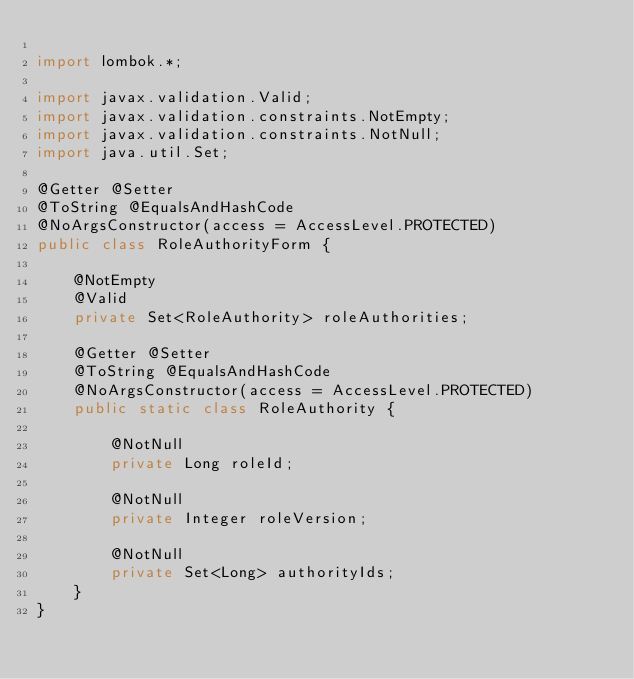<code> <loc_0><loc_0><loc_500><loc_500><_Java_>
import lombok.*;

import javax.validation.Valid;
import javax.validation.constraints.NotEmpty;
import javax.validation.constraints.NotNull;
import java.util.Set;

@Getter @Setter
@ToString @EqualsAndHashCode
@NoArgsConstructor(access = AccessLevel.PROTECTED)
public class RoleAuthorityForm {

    @NotEmpty
    @Valid
    private Set<RoleAuthority> roleAuthorities;

    @Getter @Setter
    @ToString @EqualsAndHashCode
    @NoArgsConstructor(access = AccessLevel.PROTECTED)
    public static class RoleAuthority {

        @NotNull
        private Long roleId;

        @NotNull
        private Integer roleVersion;

        @NotNull
        private Set<Long> authorityIds;
    }
}
</code> 